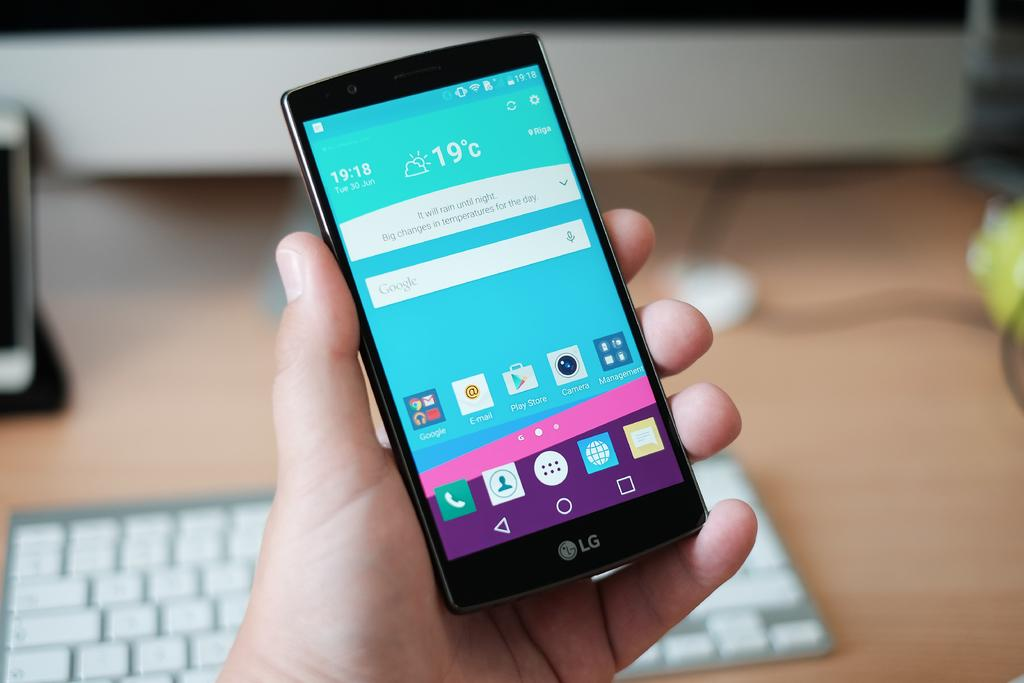<image>
Offer a succinct explanation of the picture presented. a phone that has the number 19 on it 